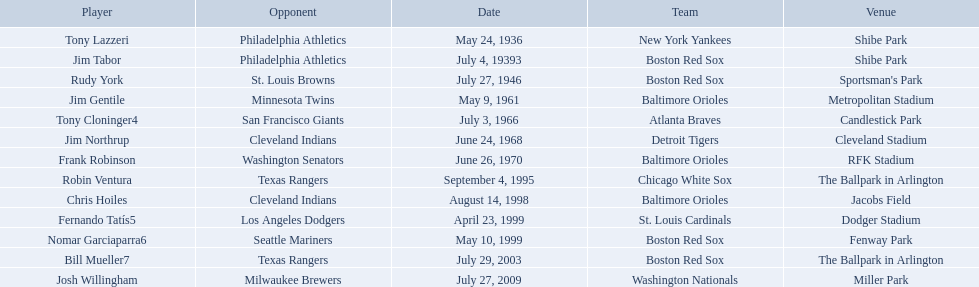Which teams played between the years 1960 and 1970? Baltimore Orioles, Atlanta Braves, Detroit Tigers, Baltimore Orioles. Of these teams that played, which ones played against the cleveland indians? Detroit Tigers. On what day did these two teams play? June 24, 1968. 